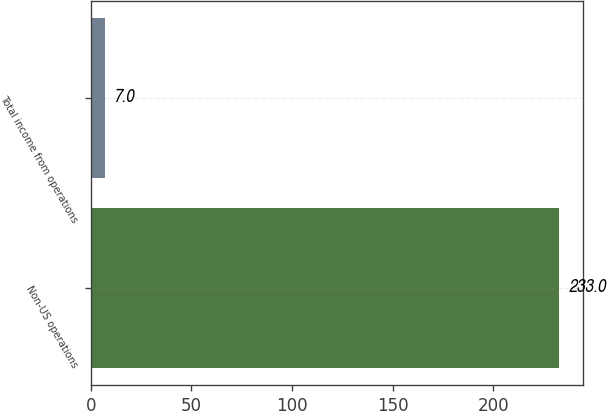Convert chart. <chart><loc_0><loc_0><loc_500><loc_500><bar_chart><fcel>Non-US operations<fcel>Total income from operations<nl><fcel>233<fcel>7<nl></chart> 